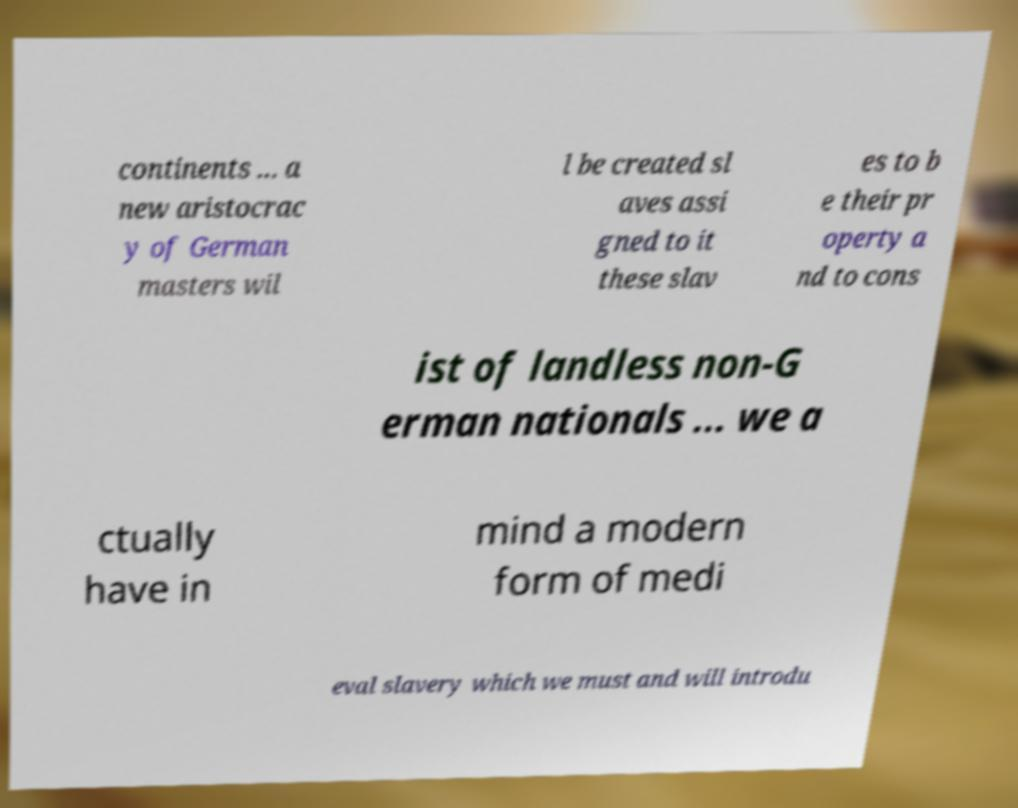Can you accurately transcribe the text from the provided image for me? continents ... a new aristocrac y of German masters wil l be created sl aves assi gned to it these slav es to b e their pr operty a nd to cons ist of landless non-G erman nationals ... we a ctually have in mind a modern form of medi eval slavery which we must and will introdu 